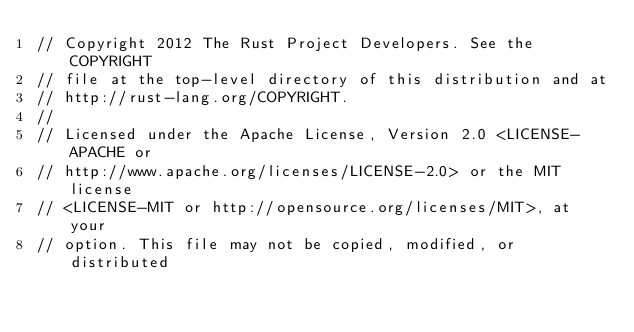<code> <loc_0><loc_0><loc_500><loc_500><_Rust_>// Copyright 2012 The Rust Project Developers. See the COPYRIGHT
// file at the top-level directory of this distribution and at
// http://rust-lang.org/COPYRIGHT.
//
// Licensed under the Apache License, Version 2.0 <LICENSE-APACHE or
// http://www.apache.org/licenses/LICENSE-2.0> or the MIT license
// <LICENSE-MIT or http://opensource.org/licenses/MIT>, at your
// option. This file may not be copied, modified, or distributed</code> 